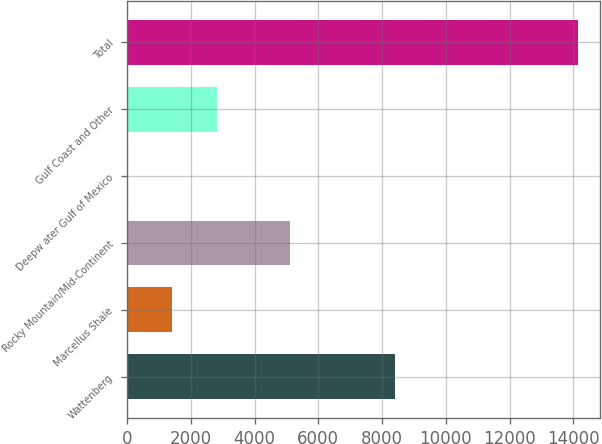Convert chart to OTSL. <chart><loc_0><loc_0><loc_500><loc_500><bar_chart><fcel>Wattenberg<fcel>Marcellus Shale<fcel>Rocky Mountain/Mid-Continent<fcel>Deepw ater Gulf of Mexico<fcel>Gulf Coast and Other<fcel>Total<nl><fcel>8415<fcel>1419.7<fcel>5120<fcel>7<fcel>2832.4<fcel>14134<nl></chart> 